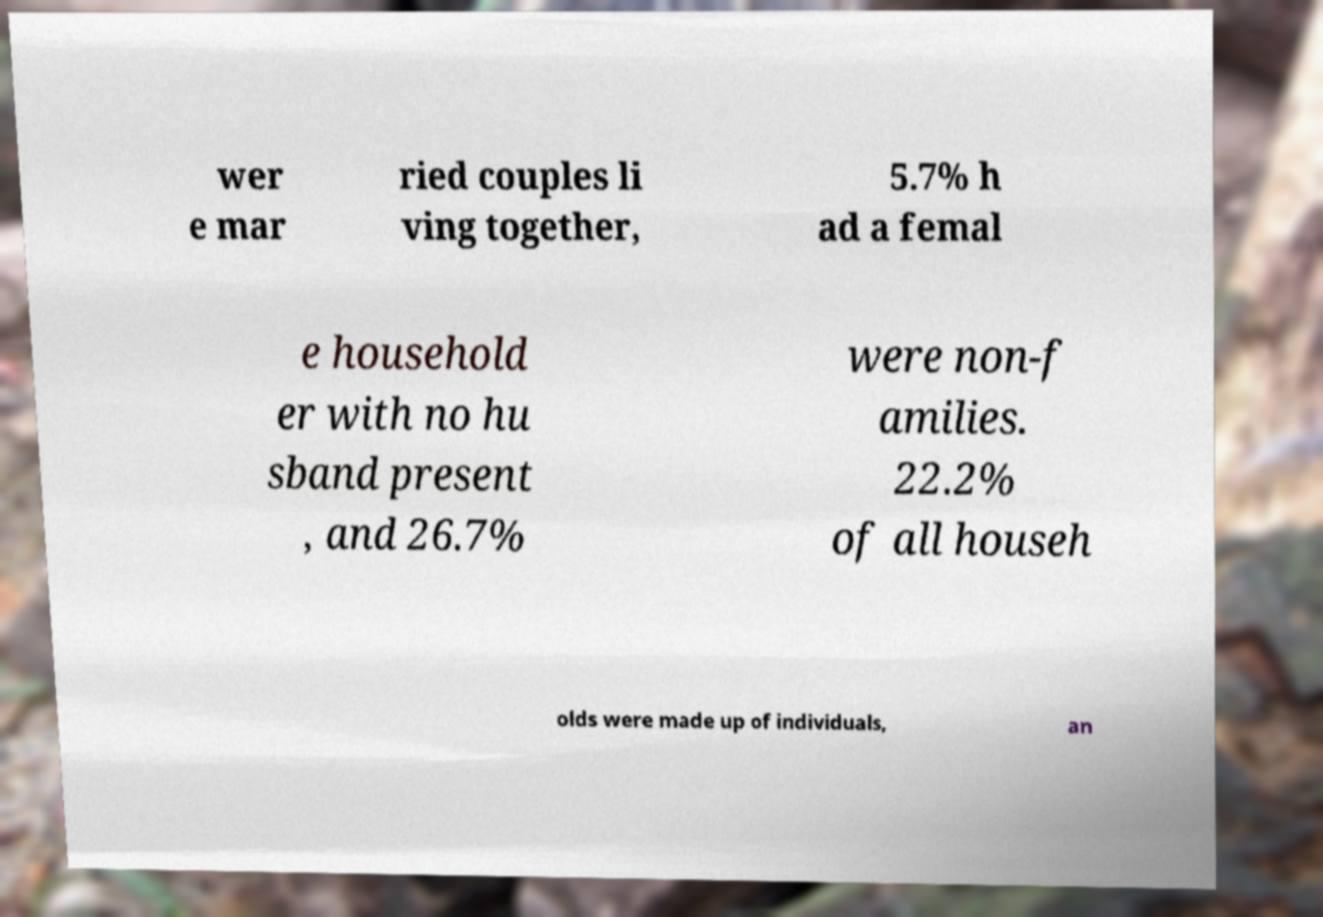I need the written content from this picture converted into text. Can you do that? wer e mar ried couples li ving together, 5.7% h ad a femal e household er with no hu sband present , and 26.7% were non-f amilies. 22.2% of all househ olds were made up of individuals, an 